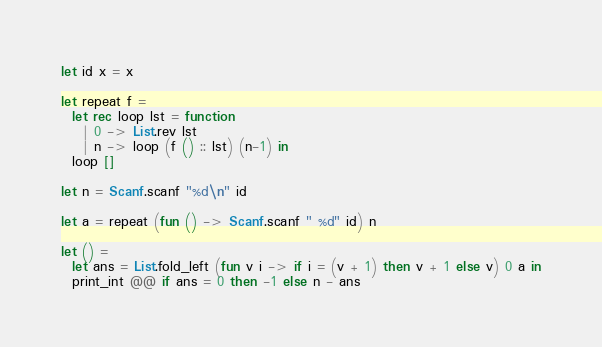<code> <loc_0><loc_0><loc_500><loc_500><_OCaml_>let id x = x

let repeat f = 
  let rec loop lst = function
    | 0 -> List.rev lst
    | n -> loop (f () :: lst) (n-1) in
  loop []

let n = Scanf.scanf "%d\n" id

let a = repeat (fun () -> Scanf.scanf " %d" id) n

let () = 
  let ans = List.fold_left (fun v i -> if i = (v + 1) then v + 1 else v) 0 a in
  print_int @@ if ans = 0 then -1 else n - ans</code> 